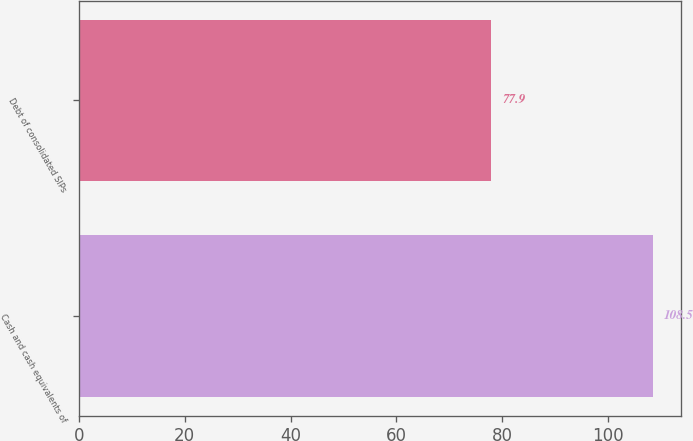<chart> <loc_0><loc_0><loc_500><loc_500><bar_chart><fcel>Cash and cash equivalents of<fcel>Debt of consolidated SIPs<nl><fcel>108.5<fcel>77.9<nl></chart> 